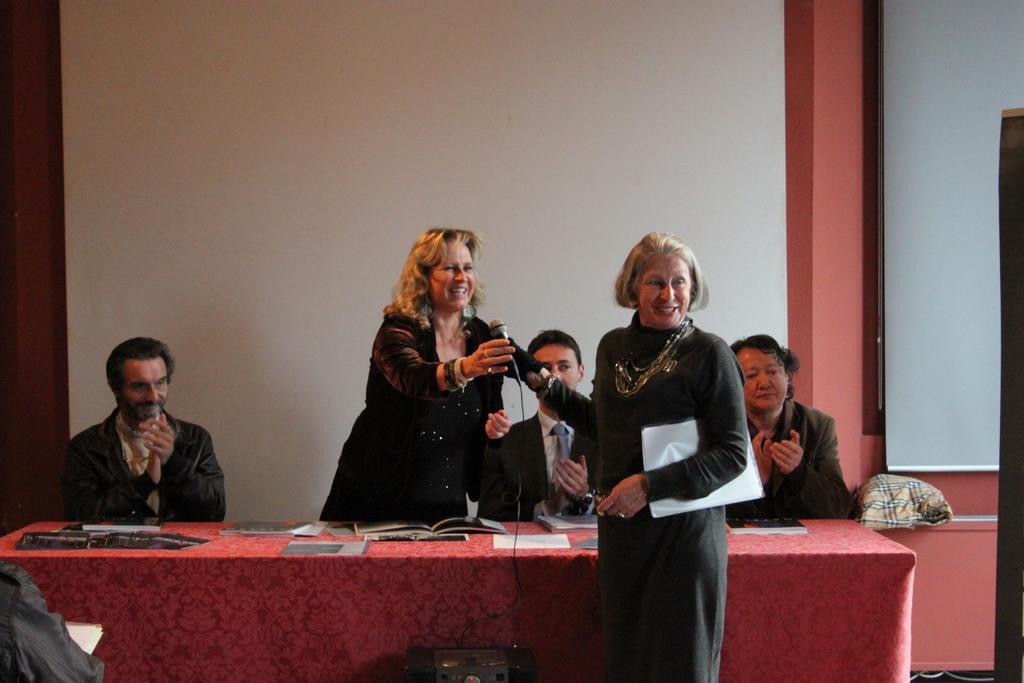Please provide a concise description of this image. In this image there is a woman on the right side who is holding the paper with one hand and trying to hold the mic which is given by another woman who is standing beside her. In the middle there is a table on which there are books,photos and papers. Behind the table there are three people who are sitting in the chairs and clapping. In the background there is a wall. At the bottom there is a wire. On the right side there is a cloth. Beside the cloth there is a screen. On the left side bottom there is a person. 